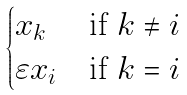<formula> <loc_0><loc_0><loc_500><loc_500>\begin{cases} x _ { k } & \text {if $k\ne i$} \\ \varepsilon x _ { i } & \text {if $k=i$} \\ \end{cases}</formula> 